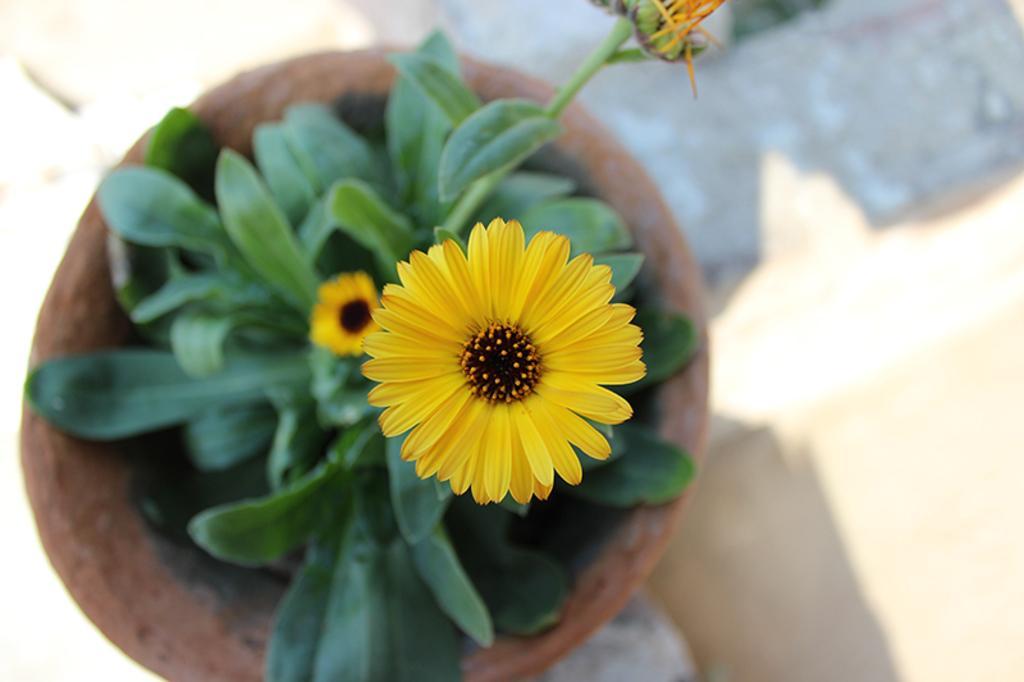Please provide a concise description of this image. In this image there is a plant pot with a plant with two flowers on it. This is the ground. 